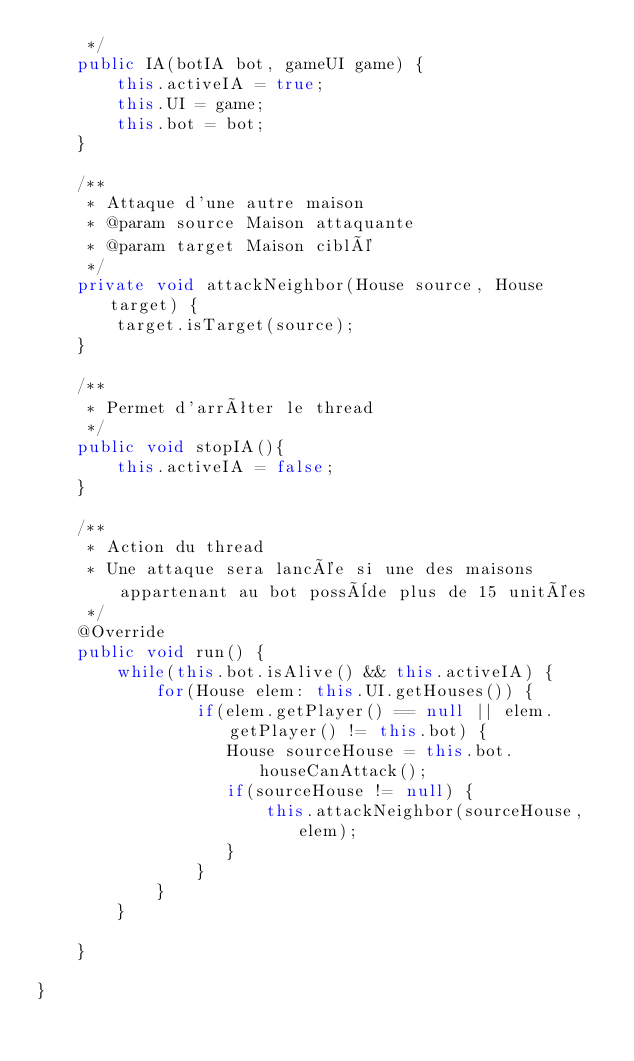Convert code to text. <code><loc_0><loc_0><loc_500><loc_500><_Java_>     */
    public IA(botIA bot, gameUI game) {
        this.activeIA = true;
        this.UI = game;
        this.bot = bot;
    }

    /**
     * Attaque d'une autre maison
     * @param source Maison attaquante
     * @param target Maison ciblé
     */
    private void attackNeighbor(House source, House target) {
        target.isTarget(source);
    }
    
    /**
     * Permet d'arrêter le thread
     */
    public void stopIA(){
        this.activeIA = false;
    }
    
    /**
     * Action du thread
     * Une attaque sera lancée si une des maisons appartenant au bot possède plus de 15 unitées
     */
    @Override
    public void run() {
        while(this.bot.isAlive() && this.activeIA) {
            for(House elem: this.UI.getHouses()) {
                if(elem.getPlayer() == null || elem.getPlayer() != this.bot) {
                   House sourceHouse = this.bot.houseCanAttack();
                   if(sourceHouse != null) {
                       this.attackNeighbor(sourceHouse, elem);
                   }
                }
            }            
        }

    }
        
}
</code> 